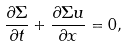<formula> <loc_0><loc_0><loc_500><loc_500>\frac { \partial \Sigma } { \partial t } + \frac { \partial \Sigma u } { \partial x } = 0 ,</formula> 